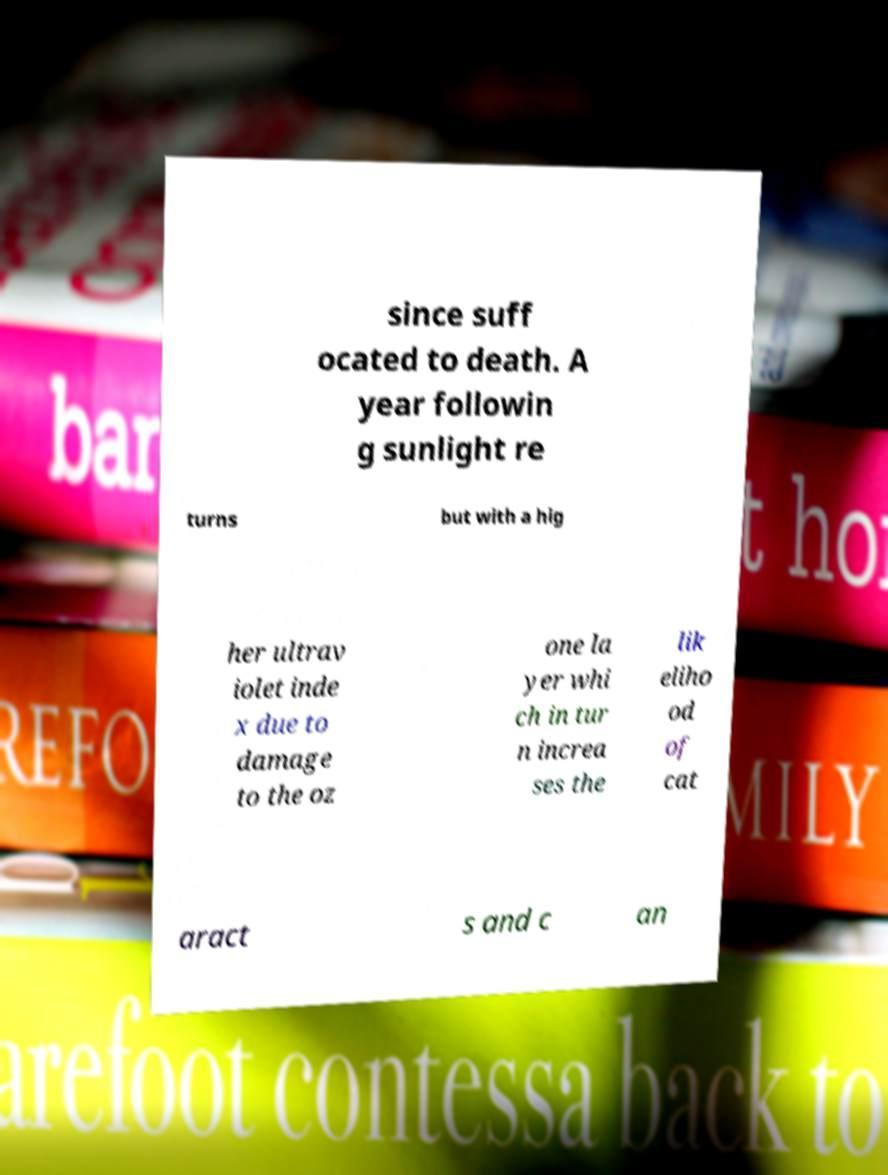Can you read and provide the text displayed in the image?This photo seems to have some interesting text. Can you extract and type it out for me? since suff ocated to death. A year followin g sunlight re turns but with a hig her ultrav iolet inde x due to damage to the oz one la yer whi ch in tur n increa ses the lik eliho od of cat aract s and c an 